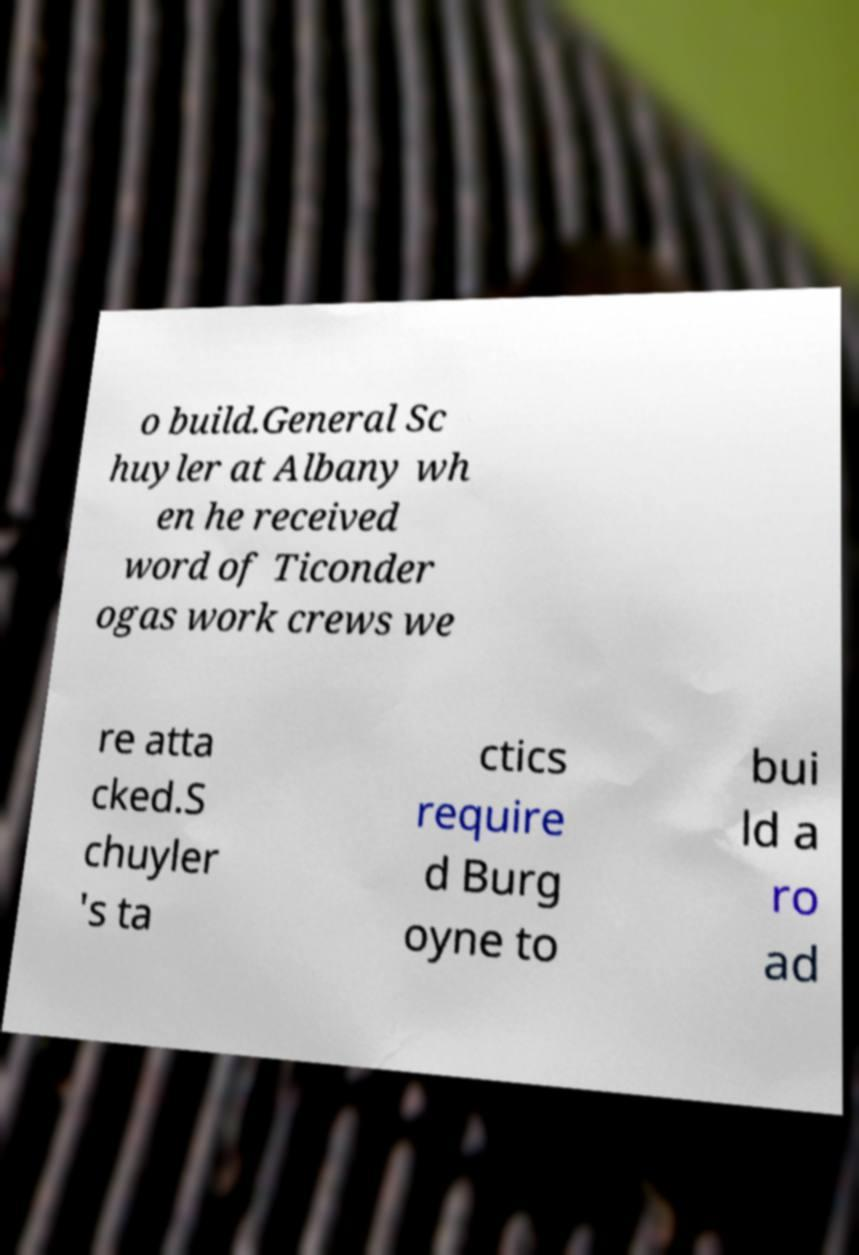Please read and relay the text visible in this image. What does it say? o build.General Sc huyler at Albany wh en he received word of Ticonder ogas work crews we re atta cked.S chuyler 's ta ctics require d Burg oyne to bui ld a ro ad 